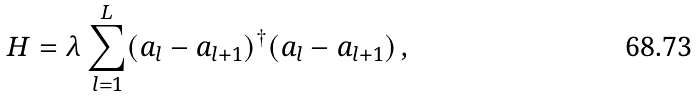Convert formula to latex. <formula><loc_0><loc_0><loc_500><loc_500>H = \lambda \sum _ { l = 1 } ^ { L } ( a _ { l } - a _ { l + 1 } ) ^ { \dagger } ( a _ { l } - a _ { l + 1 } ) \, ,</formula> 